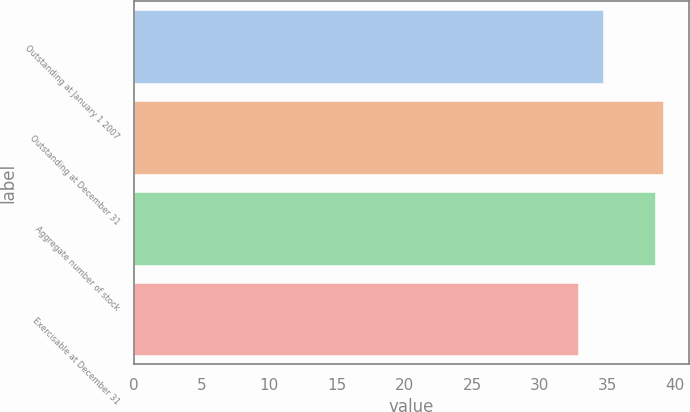Convert chart to OTSL. <chart><loc_0><loc_0><loc_500><loc_500><bar_chart><fcel>Outstanding at January 1 2007<fcel>Outstanding at December 31<fcel>Aggregate number of stock<fcel>Exercisable at December 31<nl><fcel>34.68<fcel>39.09<fcel>38.49<fcel>32.83<nl></chart> 